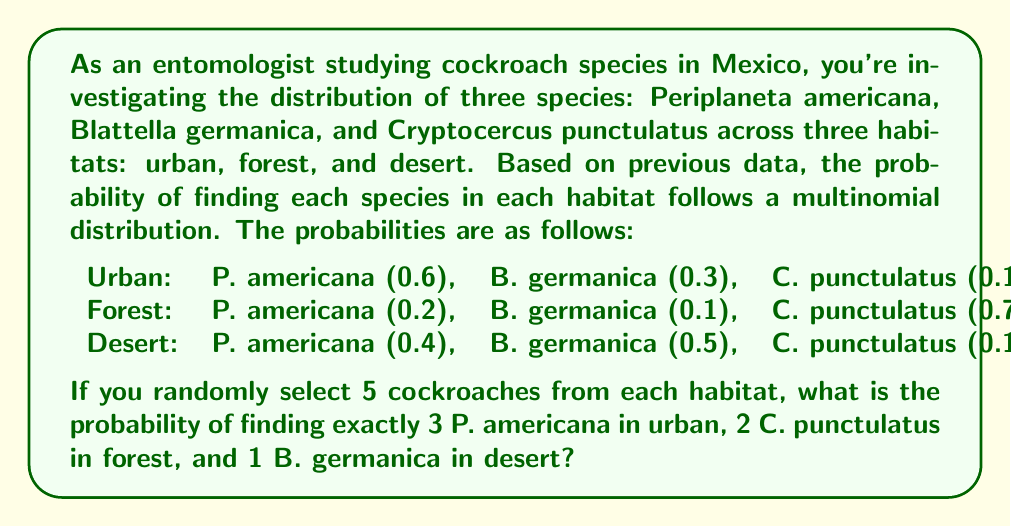Solve this math problem. To solve this problem, we need to use the multinomial probability distribution for each habitat and then multiply the probabilities together. The multinomial probability mass function is:

$$ P(X_1 = x_1, ..., X_k = x_k) = \frac{n!}{x_1! \cdots x_k!} p_1^{x_1} \cdots p_k^{x_k} $$

Where $n$ is the total number of trials, $x_i$ is the number of occurrences of each outcome, and $p_i$ is the probability of each outcome.

Let's calculate the probability for each habitat:

1. Urban habitat (3 P. americana, 2 others):
   $$ P(X_1 = 3, X_2 = 2) = \frac{5!}{3!2!} (0.6)^3 (0.4)^2 = 10 \cdot 0.216 \cdot 0.16 = 0.3456 $$

2. Forest habitat (2 C. punctulatus, 3 others):
   $$ P(X_1 = 2, X_2 = 3) = \frac{5!}{2!3!} (0.7)^2 (0.3)^3 = 10 \cdot 0.49 \cdot 0.027 = 0.1323 $$

3. Desert habitat (1 B. germanica, 4 others):
   $$ P(X_1 = 1, X_2 = 4) = \frac{5!}{1!4!} (0.5)^1 (0.5)^4 = 5 \cdot 0.5 \cdot 0.0625 = 0.15625 $$

Now, we multiply these probabilities together to get the final probability:

$$ 0.3456 \cdot 0.1323 \cdot 0.15625 = 0.00714 $$
Answer: 0.00714 